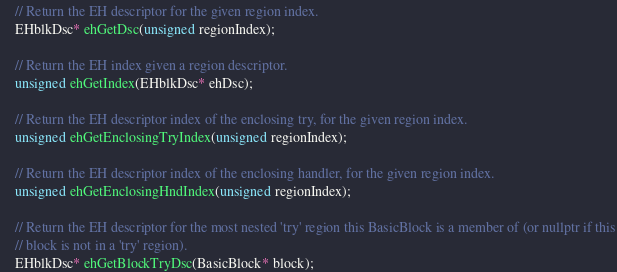<code> <loc_0><loc_0><loc_500><loc_500><_C_>    // Return the EH descriptor for the given region index.
    EHblkDsc* ehGetDsc(unsigned regionIndex);

    // Return the EH index given a region descriptor.
    unsigned ehGetIndex(EHblkDsc* ehDsc);

    // Return the EH descriptor index of the enclosing try, for the given region index.
    unsigned ehGetEnclosingTryIndex(unsigned regionIndex);

    // Return the EH descriptor index of the enclosing handler, for the given region index.
    unsigned ehGetEnclosingHndIndex(unsigned regionIndex);

    // Return the EH descriptor for the most nested 'try' region this BasicBlock is a member of (or nullptr if this
    // block is not in a 'try' region).
    EHblkDsc* ehGetBlockTryDsc(BasicBlock* block);
</code> 